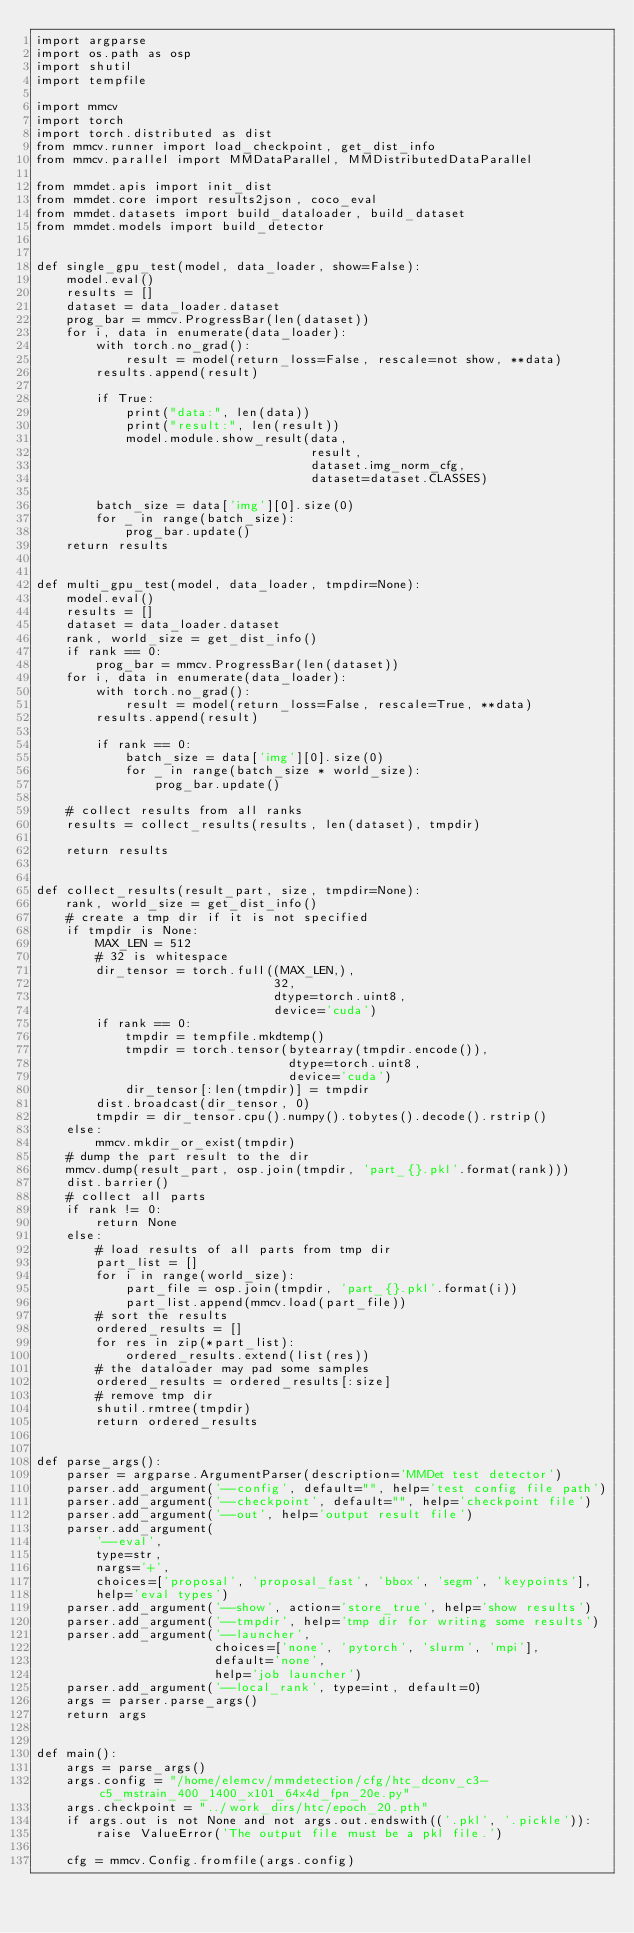<code> <loc_0><loc_0><loc_500><loc_500><_Python_>import argparse
import os.path as osp
import shutil
import tempfile

import mmcv
import torch
import torch.distributed as dist
from mmcv.runner import load_checkpoint, get_dist_info
from mmcv.parallel import MMDataParallel, MMDistributedDataParallel

from mmdet.apis import init_dist
from mmdet.core import results2json, coco_eval
from mmdet.datasets import build_dataloader, build_dataset
from mmdet.models import build_detector


def single_gpu_test(model, data_loader, show=False):
    model.eval()
    results = []
    dataset = data_loader.dataset
    prog_bar = mmcv.ProgressBar(len(dataset))
    for i, data in enumerate(data_loader):
        with torch.no_grad():
            result = model(return_loss=False, rescale=not show, **data)
        results.append(result)

        if True:
            print("data:", len(data))
            print("result:", len(result))
            model.module.show_result(data,
                                     result,
                                     dataset.img_norm_cfg,
                                     dataset=dataset.CLASSES)

        batch_size = data['img'][0].size(0)
        for _ in range(batch_size):
            prog_bar.update()
    return results


def multi_gpu_test(model, data_loader, tmpdir=None):
    model.eval()
    results = []
    dataset = data_loader.dataset
    rank, world_size = get_dist_info()
    if rank == 0:
        prog_bar = mmcv.ProgressBar(len(dataset))
    for i, data in enumerate(data_loader):
        with torch.no_grad():
            result = model(return_loss=False, rescale=True, **data)
        results.append(result)

        if rank == 0:
            batch_size = data['img'][0].size(0)
            for _ in range(batch_size * world_size):
                prog_bar.update()

    # collect results from all ranks
    results = collect_results(results, len(dataset), tmpdir)

    return results


def collect_results(result_part, size, tmpdir=None):
    rank, world_size = get_dist_info()
    # create a tmp dir if it is not specified
    if tmpdir is None:
        MAX_LEN = 512
        # 32 is whitespace
        dir_tensor = torch.full((MAX_LEN,),
                                32,
                                dtype=torch.uint8,
                                device='cuda')
        if rank == 0:
            tmpdir = tempfile.mkdtemp()
            tmpdir = torch.tensor(bytearray(tmpdir.encode()),
                                  dtype=torch.uint8,
                                  device='cuda')
            dir_tensor[:len(tmpdir)] = tmpdir
        dist.broadcast(dir_tensor, 0)
        tmpdir = dir_tensor.cpu().numpy().tobytes().decode().rstrip()
    else:
        mmcv.mkdir_or_exist(tmpdir)
    # dump the part result to the dir
    mmcv.dump(result_part, osp.join(tmpdir, 'part_{}.pkl'.format(rank)))
    dist.barrier()
    # collect all parts
    if rank != 0:
        return None
    else:
        # load results of all parts from tmp dir
        part_list = []
        for i in range(world_size):
            part_file = osp.join(tmpdir, 'part_{}.pkl'.format(i))
            part_list.append(mmcv.load(part_file))
        # sort the results
        ordered_results = []
        for res in zip(*part_list):
            ordered_results.extend(list(res))
        # the dataloader may pad some samples
        ordered_results = ordered_results[:size]
        # remove tmp dir
        shutil.rmtree(tmpdir)
        return ordered_results


def parse_args():
    parser = argparse.ArgumentParser(description='MMDet test detector')
    parser.add_argument('--config', default="", help='test config file path')
    parser.add_argument('--checkpoint', default="", help='checkpoint file')
    parser.add_argument('--out', help='output result file')
    parser.add_argument(
        '--eval',
        type=str,
        nargs='+',
        choices=['proposal', 'proposal_fast', 'bbox', 'segm', 'keypoints'],
        help='eval types')
    parser.add_argument('--show', action='store_true', help='show results')
    parser.add_argument('--tmpdir', help='tmp dir for writing some results')
    parser.add_argument('--launcher',
                        choices=['none', 'pytorch', 'slurm', 'mpi'],
                        default='none',
                        help='job launcher')
    parser.add_argument('--local_rank', type=int, default=0)
    args = parser.parse_args()
    return args


def main():
    args = parse_args()
    args.config = "/home/elemcv/mmdetection/cfg/htc_dconv_c3-c5_mstrain_400_1400_x101_64x4d_fpn_20e.py"
    args.checkpoint = "../work_dirs/htc/epoch_20.pth"
    if args.out is not None and not args.out.endswith(('.pkl', '.pickle')):
        raise ValueError('The output file must be a pkl file.')

    cfg = mmcv.Config.fromfile(args.config)</code> 